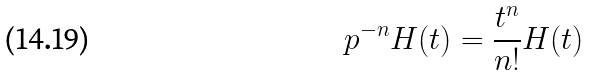Convert formula to latex. <formula><loc_0><loc_0><loc_500><loc_500>p ^ { - n } H ( t ) = \frac { t ^ { n } } { n ! } H ( t )</formula> 